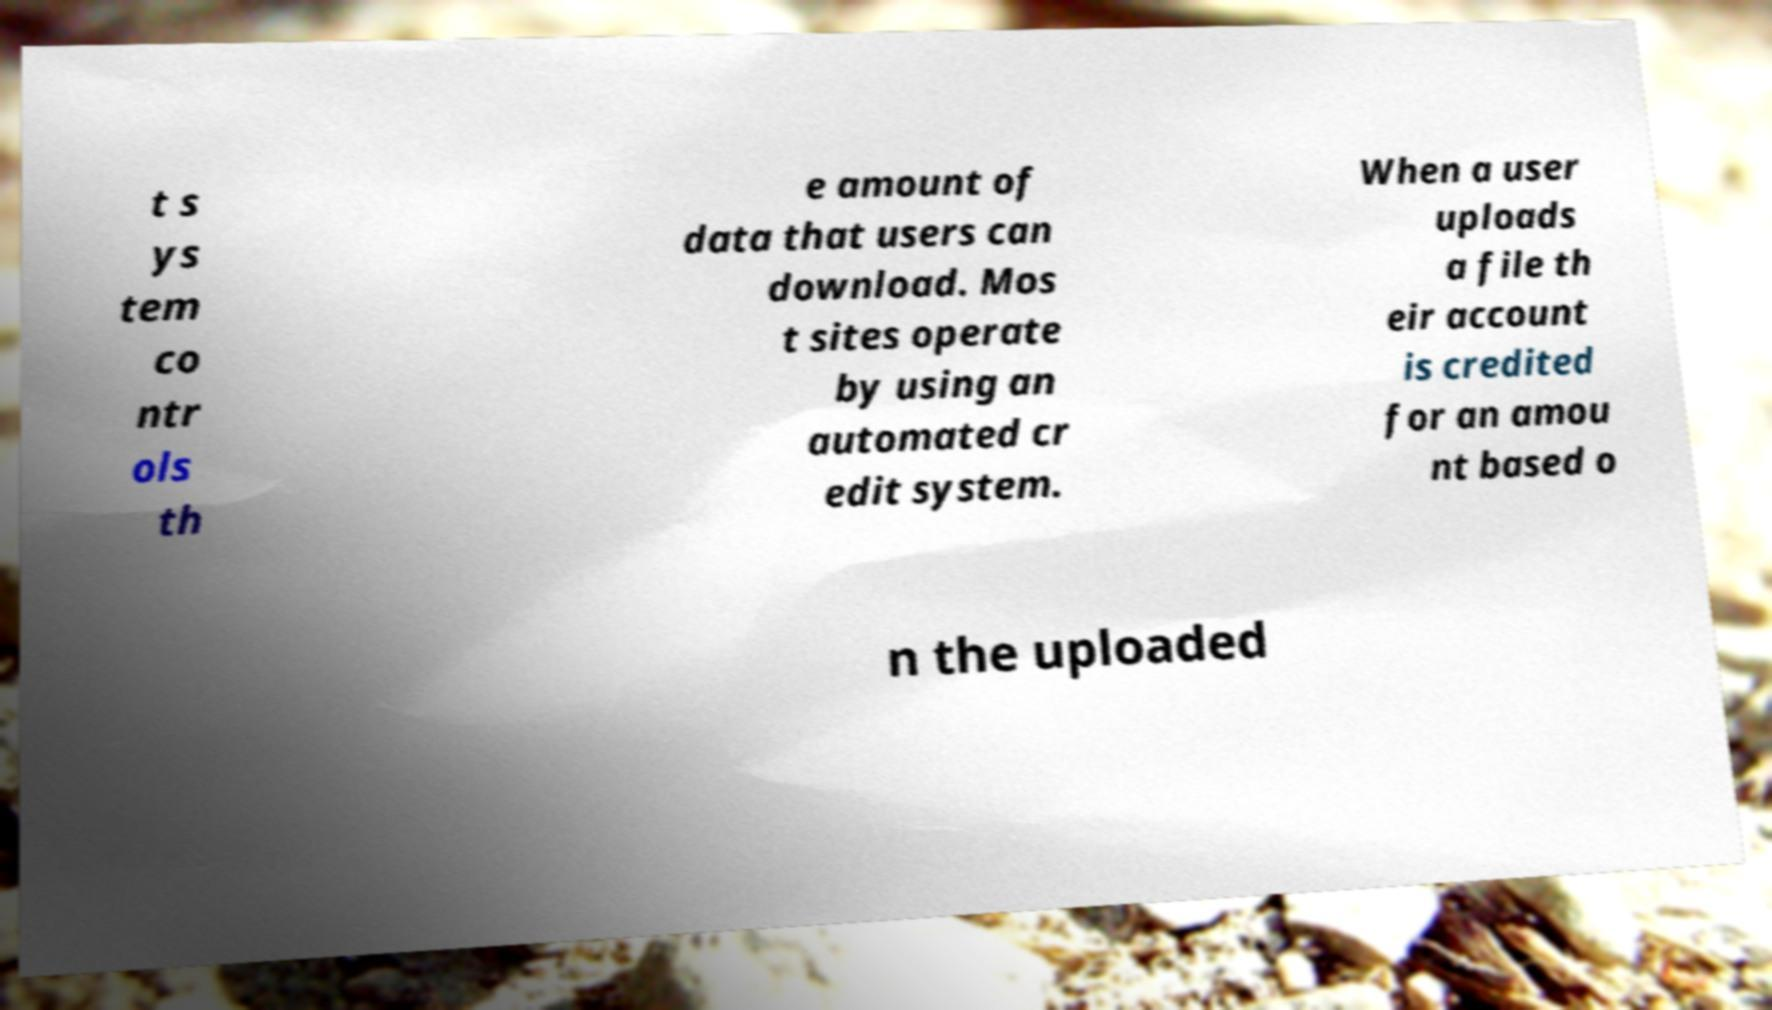For documentation purposes, I need the text within this image transcribed. Could you provide that? t s ys tem co ntr ols th e amount of data that users can download. Mos t sites operate by using an automated cr edit system. When a user uploads a file th eir account is credited for an amou nt based o n the uploaded 